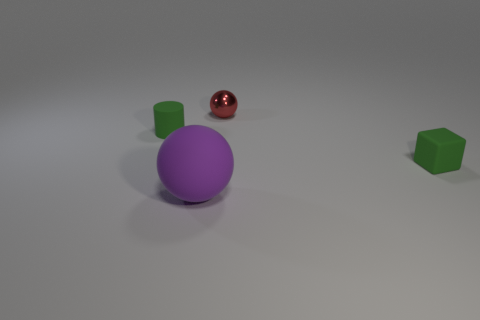Add 1 green rubber cylinders. How many objects exist? 5 Subtract all blocks. How many objects are left? 3 Subtract 0 gray cubes. How many objects are left? 4 Subtract all rubber cylinders. Subtract all big brown cylinders. How many objects are left? 3 Add 3 tiny green rubber cylinders. How many tiny green rubber cylinders are left? 4 Add 1 matte balls. How many matte balls exist? 2 